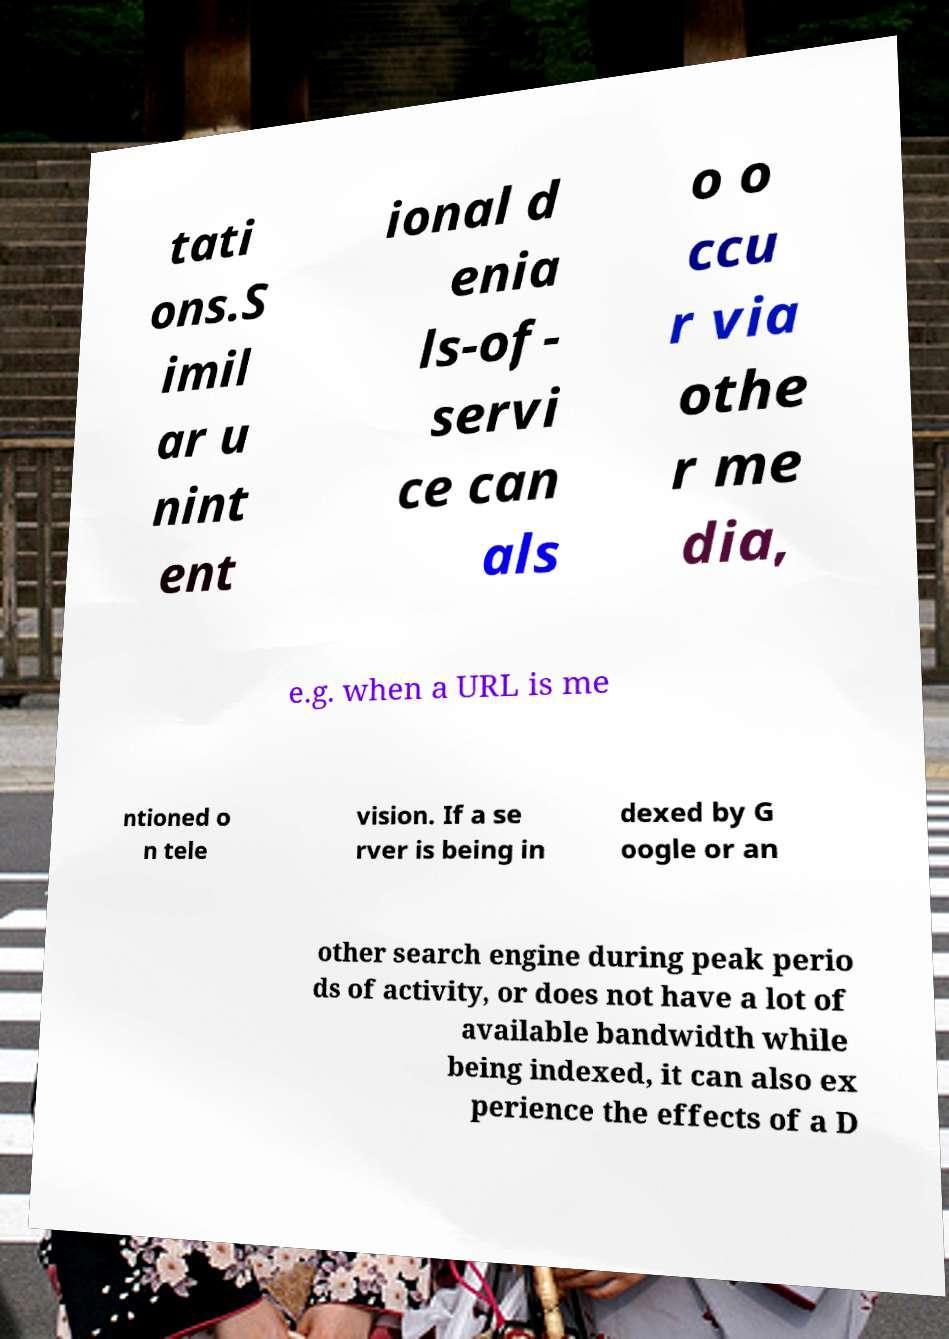Can you read and provide the text displayed in the image?This photo seems to have some interesting text. Can you extract and type it out for me? tati ons.S imil ar u nint ent ional d enia ls-of- servi ce can als o o ccu r via othe r me dia, e.g. when a URL is me ntioned o n tele vision. If a se rver is being in dexed by G oogle or an other search engine during peak perio ds of activity, or does not have a lot of available bandwidth while being indexed, it can also ex perience the effects of a D 